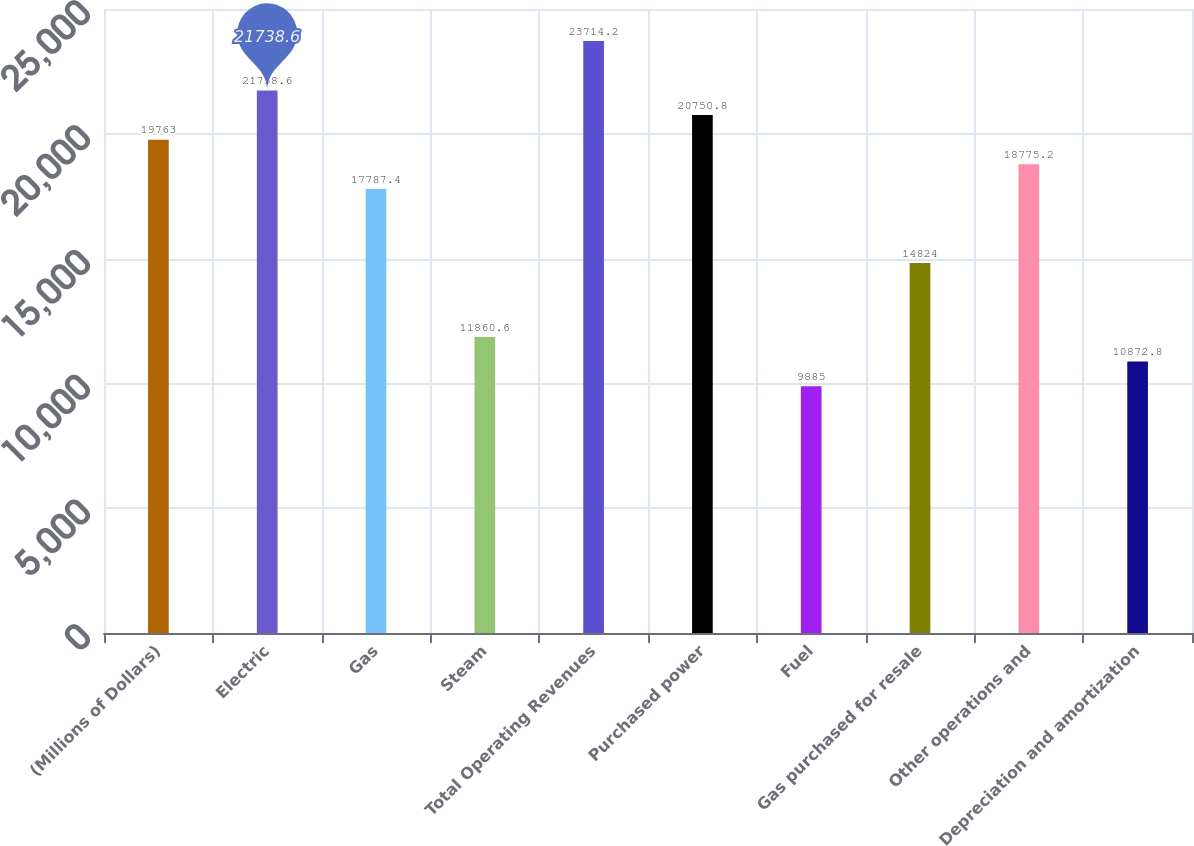<chart> <loc_0><loc_0><loc_500><loc_500><bar_chart><fcel>(Millions of Dollars)<fcel>Electric<fcel>Gas<fcel>Steam<fcel>Total Operating Revenues<fcel>Purchased power<fcel>Fuel<fcel>Gas purchased for resale<fcel>Other operations and<fcel>Depreciation and amortization<nl><fcel>19763<fcel>21738.6<fcel>17787.4<fcel>11860.6<fcel>23714.2<fcel>20750.8<fcel>9885<fcel>14824<fcel>18775.2<fcel>10872.8<nl></chart> 